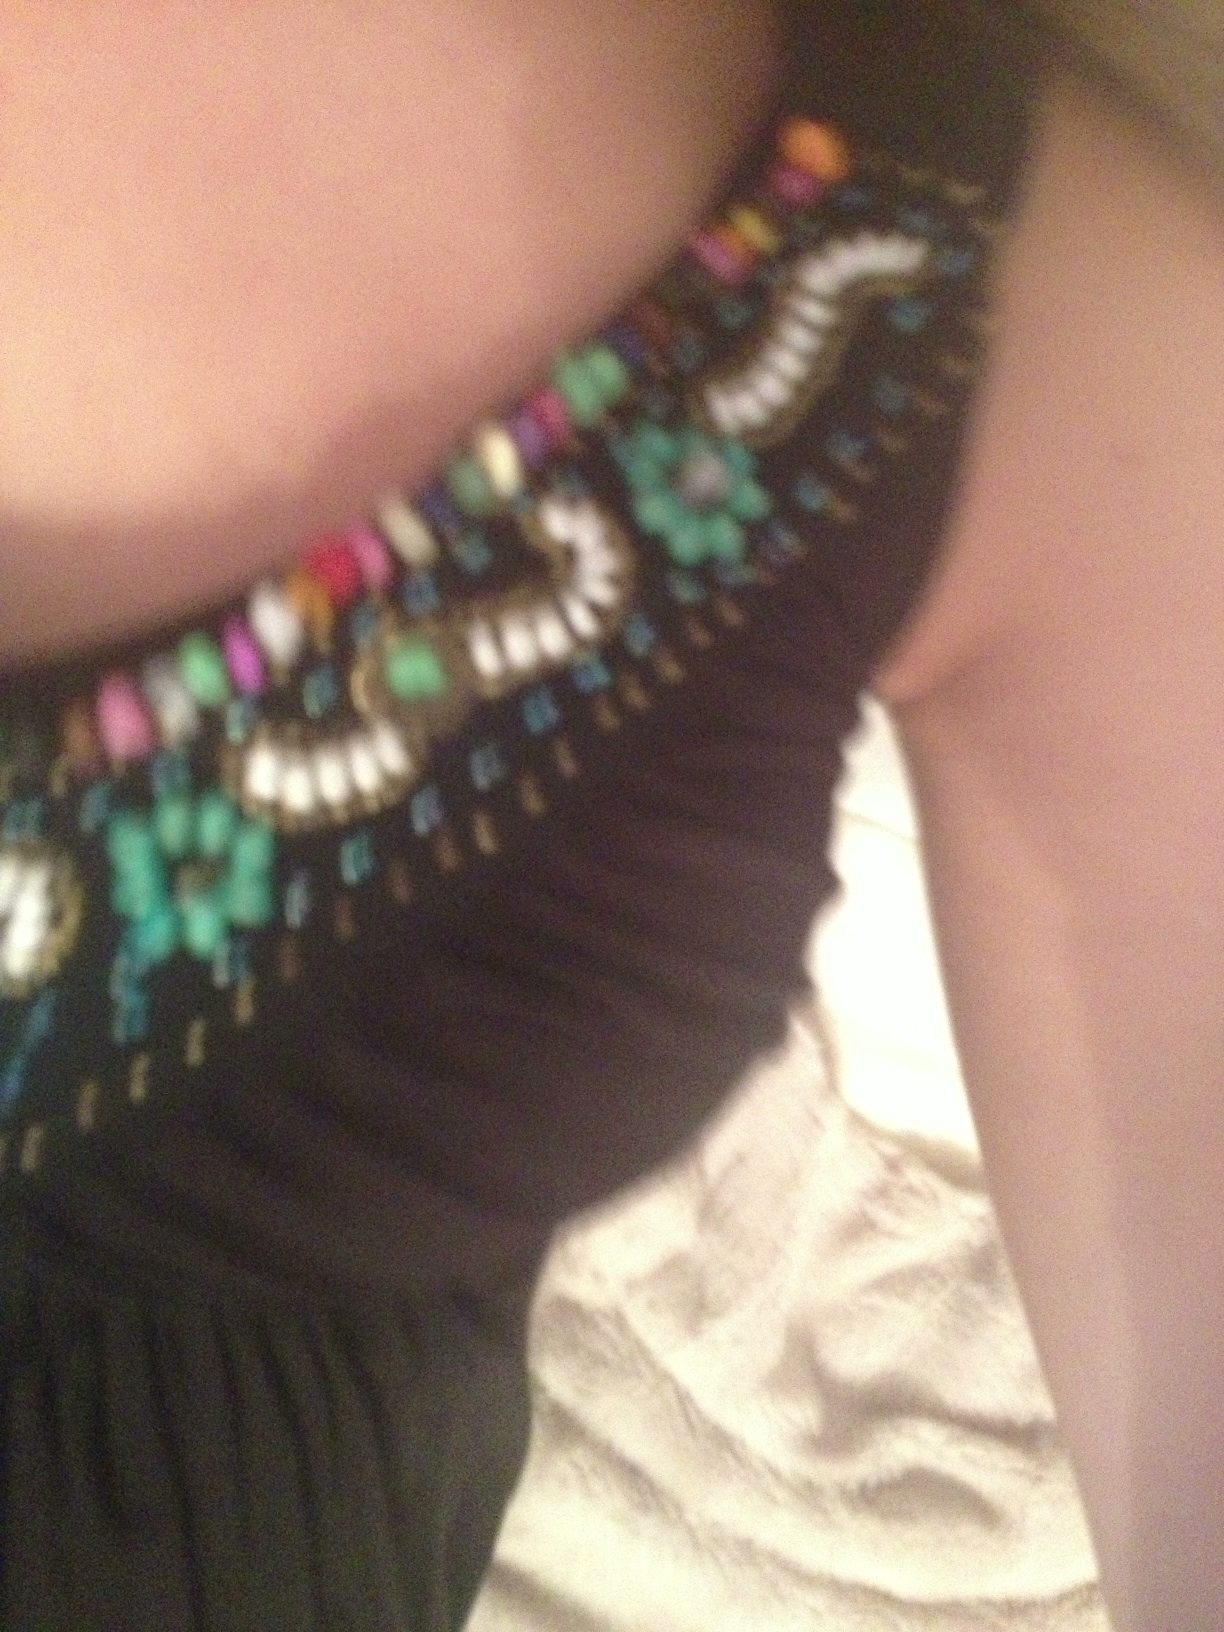What kind of outerwear should I pair with this dress for a formal evening event? For a formal evening event, consider a tailored blazer or a sleek shawl in a dark hue that echoes one of the less prominent colors in the dress's neckline. This will ensure that the outerwear complements the overall ensemble without overshadowing the dress itself. 